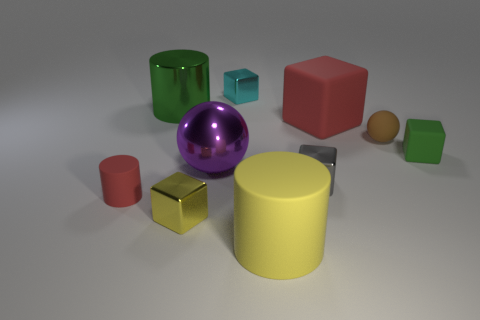Subtract all tiny blocks. How many blocks are left? 1 Subtract 2 cylinders. How many cylinders are left? 1 Subtract all yellow cylinders. How many cylinders are left? 2 Subtract all cylinders. How many objects are left? 7 Add 9 large green cylinders. How many large green cylinders are left? 10 Add 6 large cubes. How many large cubes exist? 7 Subtract 1 yellow cubes. How many objects are left? 9 Subtract all green cubes. Subtract all cyan balls. How many cubes are left? 4 Subtract all purple spheres. How many yellow cylinders are left? 1 Subtract all big brown shiny blocks. Subtract all big matte objects. How many objects are left? 8 